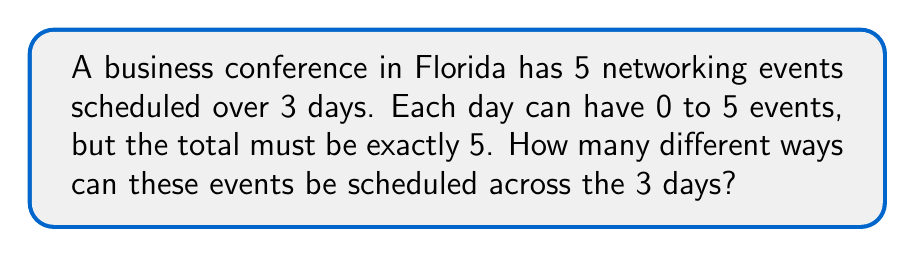Solve this math problem. Let's approach this step-by-step:

1) This is a problem of distributing 5 identical objects (events) into 3 distinct boxes (days). In combinatorics, this is known as a combination with repetition allowed.

2) The formula for combinations with repetition is:

   $$\binom{n+r-1}{r} = \binom{n+r-1}{n-1}$$

   Where $n$ is the number of types (days in this case) and $r$ is the number of objects (events).

3) In our problem:
   $n = 3$ (3 days)
   $r = 5$ (5 events)

4) Plugging these into our formula:

   $$\binom{3+5-1}{5} = \binom{7}{5}$$

5) We can calculate this as:

   $$\binom{7}{5} = \frac{7!}{5!(7-5)!} = \frac{7!}{5!2!}$$

6) Expanding this:

   $$\frac{7 * 6 * 5!}{5! * 2 * 1} = \frac{42}{2} = 21$$

Therefore, there are 21 different ways to schedule the 5 networking events across the 3 days.
Answer: 21 